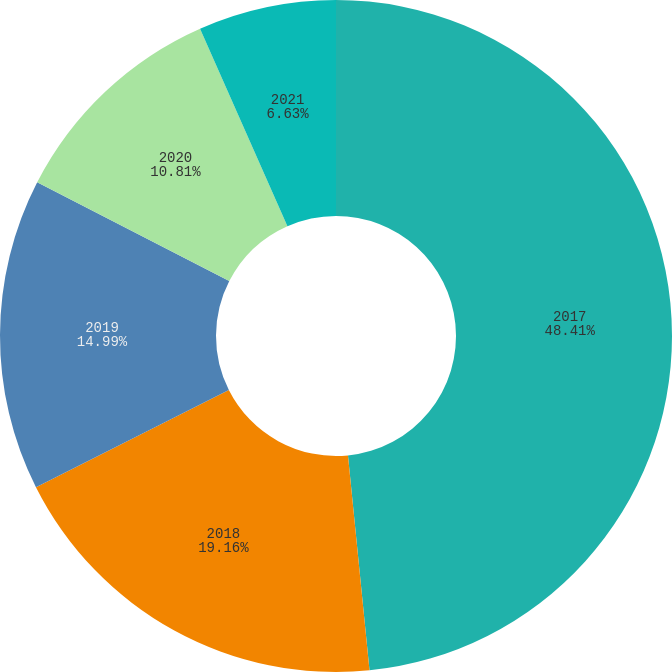Convert chart to OTSL. <chart><loc_0><loc_0><loc_500><loc_500><pie_chart><fcel>2017<fcel>2018<fcel>2019<fcel>2020<fcel>2021<nl><fcel>48.41%<fcel>19.16%<fcel>14.99%<fcel>10.81%<fcel>6.63%<nl></chart> 